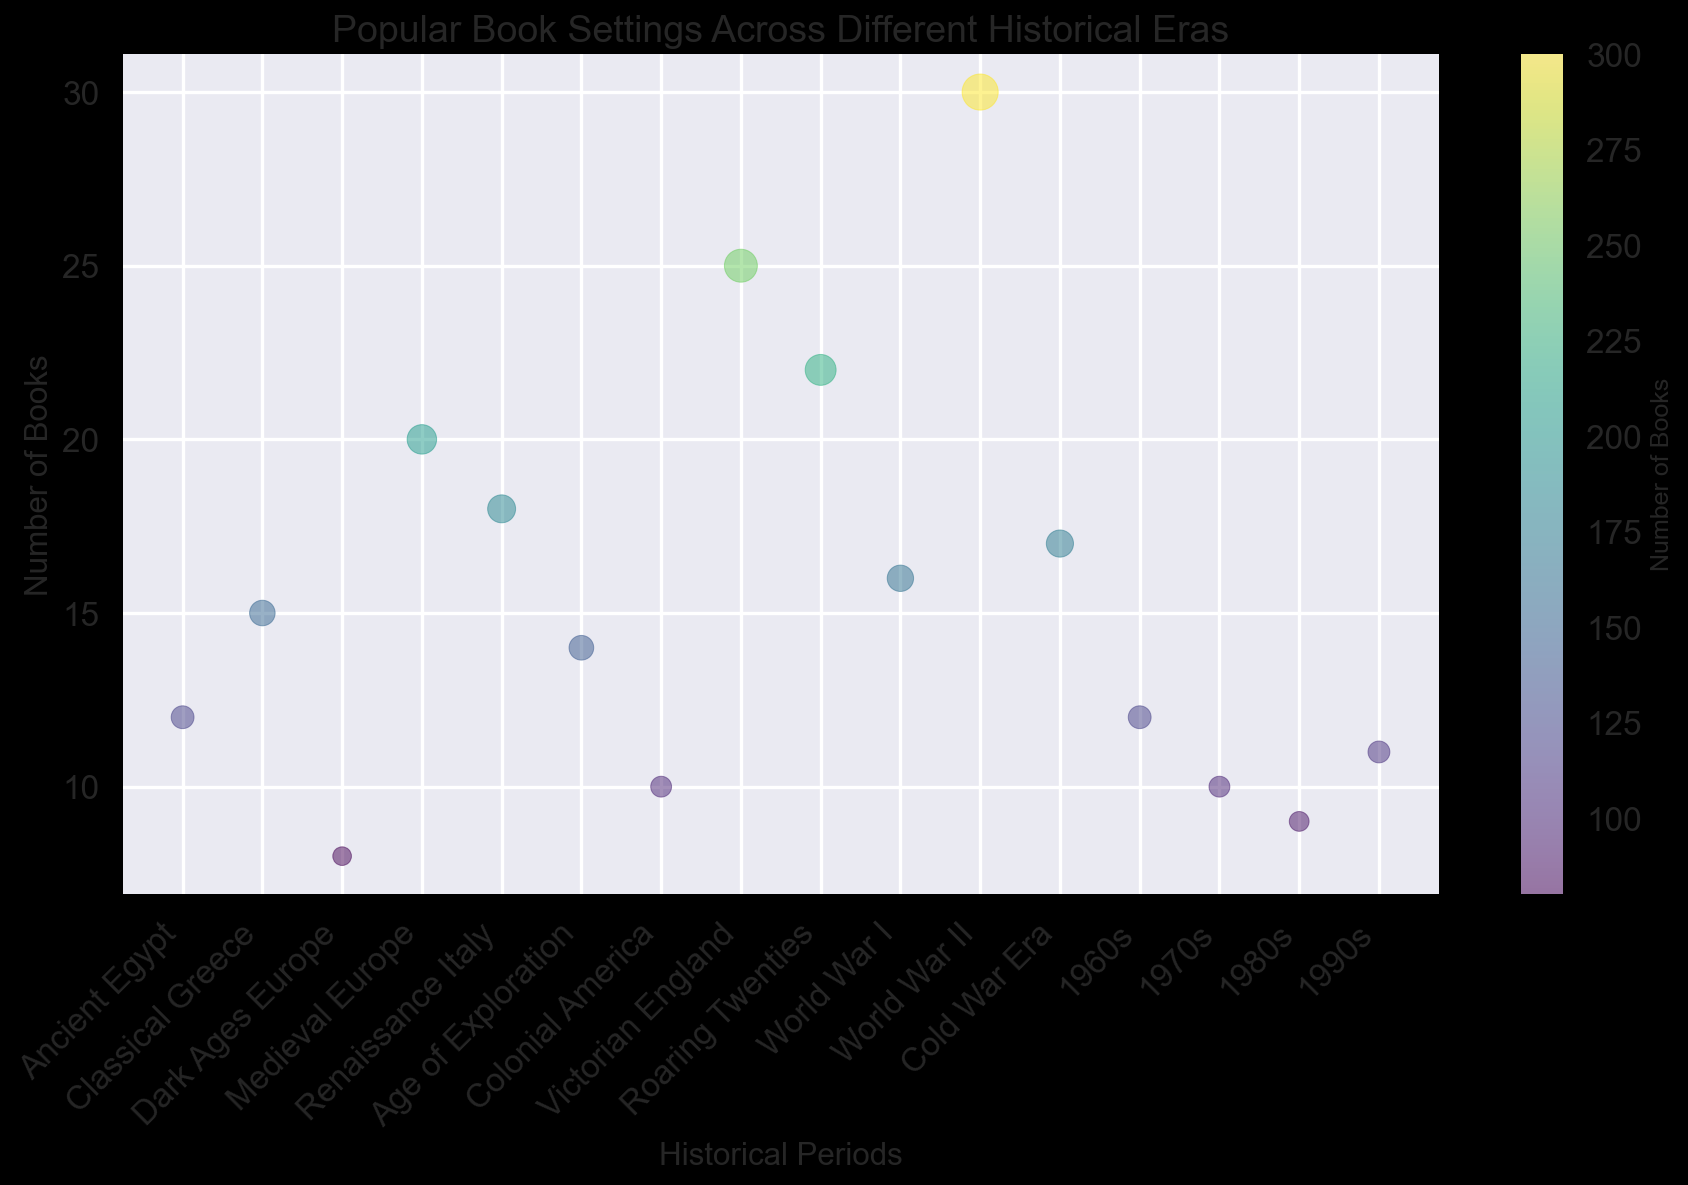Which historical period has the greatest number of books set in it? By looking at the chart, the bubble with the largest size represents the historical period with the highest number of books. In this case, the largest bubble corresponds to World War II.
Answer: World War II How many more books are set in Victorian England compared to Age of Exploration? From the chart, Victorian England has 25 books, and Age of Exploration has 14 books. The difference can be calculated as 25 - 14.
Answer: 11 Which two historical periods have an equal number of books set in them? By examining the size of the bubbles, we can see that both 1960s and Ancient Egypt have equal-sized bubbles representing 12 books each.
Answer: 1960s and Ancient Egypt What is the total number of books set in the Medieval Europe and Renaissance Italy combined? From the chart, Medieval Europe has 20 books and Renaissance Italy has 18 books. The total is calculated by adding these two values: 20 + 18.
Answer: 38 Which historical period has the second highest number of books set in it? By comparing the bubbles, the second largest bubble after World War II is Victorian England with 25 books.
Answer: Victorian England Does the number of books set in the Cold War Era surpass the number set in World War I? According to the chart, the Cold War Era has 17 books, while World War I has 16 books. Since 17 is greater than 16, the number of books in the Cold War Era surpasses the number in World War I.
Answer: Yes How many periods have more than 20 books set in them? By examining the chart, we can see that only three periods have bubbles representing more than 20 books: World War II, Victorian England, and the Roaring Twenties.
Answer: Three periods What is the average number of books for the periods from the 1960s to the 1990s? The periods are 1960s (12 books), 1970s (10 books), 1980s (9 books), and 1990s (11 books). Calculate the average: (12 + 10 + 9 + 11) / 4.
Answer: 10.5 Which historical period between Classical Greece and Age of Exploration has fewer books? According to the chart, Classical Greece has 15 books while Age of Exploration has 14 books. Therefore, Age of Exploration has fewer.
Answer: Age of Exploration 